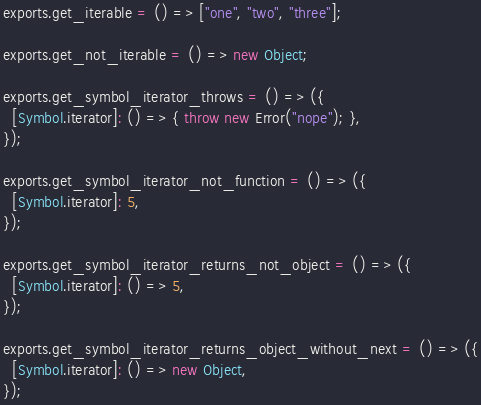Convert code to text. <code><loc_0><loc_0><loc_500><loc_500><_JavaScript_>exports.get_iterable = () => ["one", "two", "three"];

exports.get_not_iterable = () => new Object;

exports.get_symbol_iterator_throws = () => ({
  [Symbol.iterator]: () => { throw new Error("nope"); },
});

exports.get_symbol_iterator_not_function = () => ({
  [Symbol.iterator]: 5,
});

exports.get_symbol_iterator_returns_not_object = () => ({
  [Symbol.iterator]: () => 5,
});

exports.get_symbol_iterator_returns_object_without_next = () => ({
  [Symbol.iterator]: () => new Object,
});
</code> 